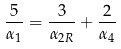Convert formula to latex. <formula><loc_0><loc_0><loc_500><loc_500>\frac { 5 } { \alpha _ { 1 } } = \frac { 3 } { \alpha _ { 2 R } } + \frac { 2 } { \alpha _ { 4 } }</formula> 